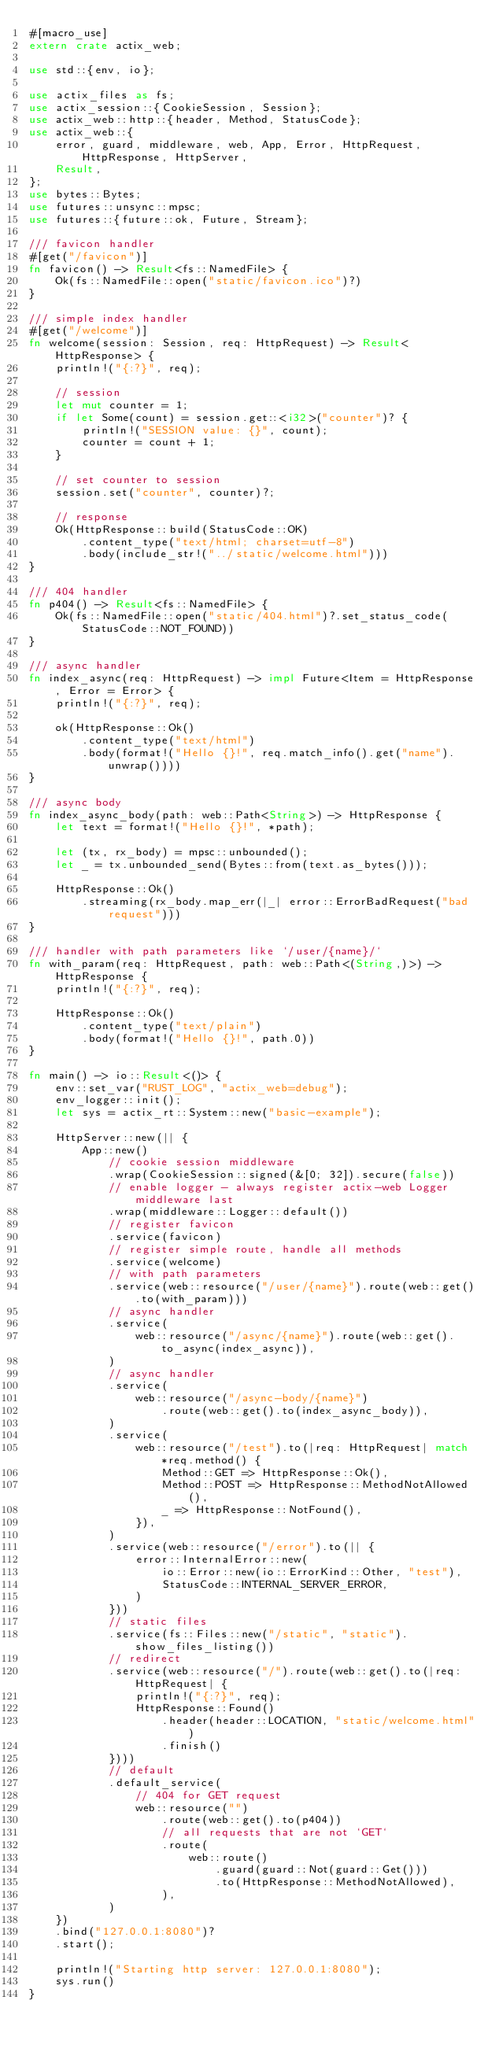Convert code to text. <code><loc_0><loc_0><loc_500><loc_500><_Rust_>#[macro_use]
extern crate actix_web;

use std::{env, io};

use actix_files as fs;
use actix_session::{CookieSession, Session};
use actix_web::http::{header, Method, StatusCode};
use actix_web::{
    error, guard, middleware, web, App, Error, HttpRequest, HttpResponse, HttpServer,
    Result,
};
use bytes::Bytes;
use futures::unsync::mpsc;
use futures::{future::ok, Future, Stream};

/// favicon handler
#[get("/favicon")]
fn favicon() -> Result<fs::NamedFile> {
    Ok(fs::NamedFile::open("static/favicon.ico")?)
}

/// simple index handler
#[get("/welcome")]
fn welcome(session: Session, req: HttpRequest) -> Result<HttpResponse> {
    println!("{:?}", req);

    // session
    let mut counter = 1;
    if let Some(count) = session.get::<i32>("counter")? {
        println!("SESSION value: {}", count);
        counter = count + 1;
    }

    // set counter to session
    session.set("counter", counter)?;

    // response
    Ok(HttpResponse::build(StatusCode::OK)
        .content_type("text/html; charset=utf-8")
        .body(include_str!("../static/welcome.html")))
}

/// 404 handler
fn p404() -> Result<fs::NamedFile> {
    Ok(fs::NamedFile::open("static/404.html")?.set_status_code(StatusCode::NOT_FOUND))
}

/// async handler
fn index_async(req: HttpRequest) -> impl Future<Item = HttpResponse, Error = Error> {
    println!("{:?}", req);

    ok(HttpResponse::Ok()
        .content_type("text/html")
        .body(format!("Hello {}!", req.match_info().get("name").unwrap())))
}

/// async body
fn index_async_body(path: web::Path<String>) -> HttpResponse {
    let text = format!("Hello {}!", *path);

    let (tx, rx_body) = mpsc::unbounded();
    let _ = tx.unbounded_send(Bytes::from(text.as_bytes()));

    HttpResponse::Ok()
        .streaming(rx_body.map_err(|_| error::ErrorBadRequest("bad request")))
}

/// handler with path parameters like `/user/{name}/`
fn with_param(req: HttpRequest, path: web::Path<(String,)>) -> HttpResponse {
    println!("{:?}", req);

    HttpResponse::Ok()
        .content_type("text/plain")
        .body(format!("Hello {}!", path.0))
}

fn main() -> io::Result<()> {
    env::set_var("RUST_LOG", "actix_web=debug");
    env_logger::init();
    let sys = actix_rt::System::new("basic-example");

    HttpServer::new(|| {
        App::new()
            // cookie session middleware
            .wrap(CookieSession::signed(&[0; 32]).secure(false))
            // enable logger - always register actix-web Logger middleware last
            .wrap(middleware::Logger::default())
            // register favicon
            .service(favicon)
            // register simple route, handle all methods
            .service(welcome)
            // with path parameters
            .service(web::resource("/user/{name}").route(web::get().to(with_param)))
            // async handler
            .service(
                web::resource("/async/{name}").route(web::get().to_async(index_async)),
            )
            // async handler
            .service(
                web::resource("/async-body/{name}")
                    .route(web::get().to(index_async_body)),
            )
            .service(
                web::resource("/test").to(|req: HttpRequest| match *req.method() {
                    Method::GET => HttpResponse::Ok(),
                    Method::POST => HttpResponse::MethodNotAllowed(),
                    _ => HttpResponse::NotFound(),
                }),
            )
            .service(web::resource("/error").to(|| {
                error::InternalError::new(
                    io::Error::new(io::ErrorKind::Other, "test"),
                    StatusCode::INTERNAL_SERVER_ERROR,
                )
            }))
            // static files
            .service(fs::Files::new("/static", "static").show_files_listing())
            // redirect
            .service(web::resource("/").route(web::get().to(|req: HttpRequest| {
                println!("{:?}", req);
                HttpResponse::Found()
                    .header(header::LOCATION, "static/welcome.html")
                    .finish()
            })))
            // default
            .default_service(
                // 404 for GET request
                web::resource("")
                    .route(web::get().to(p404))
                    // all requests that are not `GET`
                    .route(
                        web::route()
                            .guard(guard::Not(guard::Get()))
                            .to(HttpResponse::MethodNotAllowed),
                    ),
            )
    })
    .bind("127.0.0.1:8080")?
    .start();

    println!("Starting http server: 127.0.0.1:8080");
    sys.run()
}
</code> 